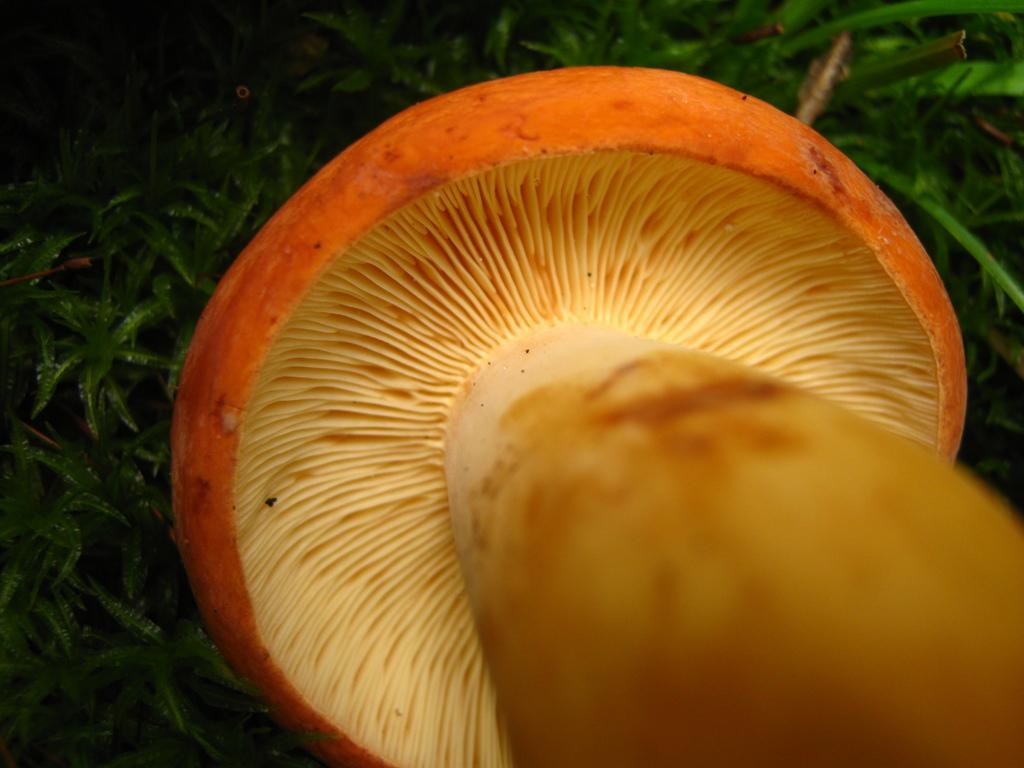What is the main subject of the image? The main subject of the image is a mushroom. Where is the mushroom located in the image? The mushroom is over a plant in the image. How is the plant represented in the image? The plant is present all over the image. What type of tomatoes can be seen growing on the person in the image? There is no person present in the image, and therefore no tomatoes can be seen growing on them. 